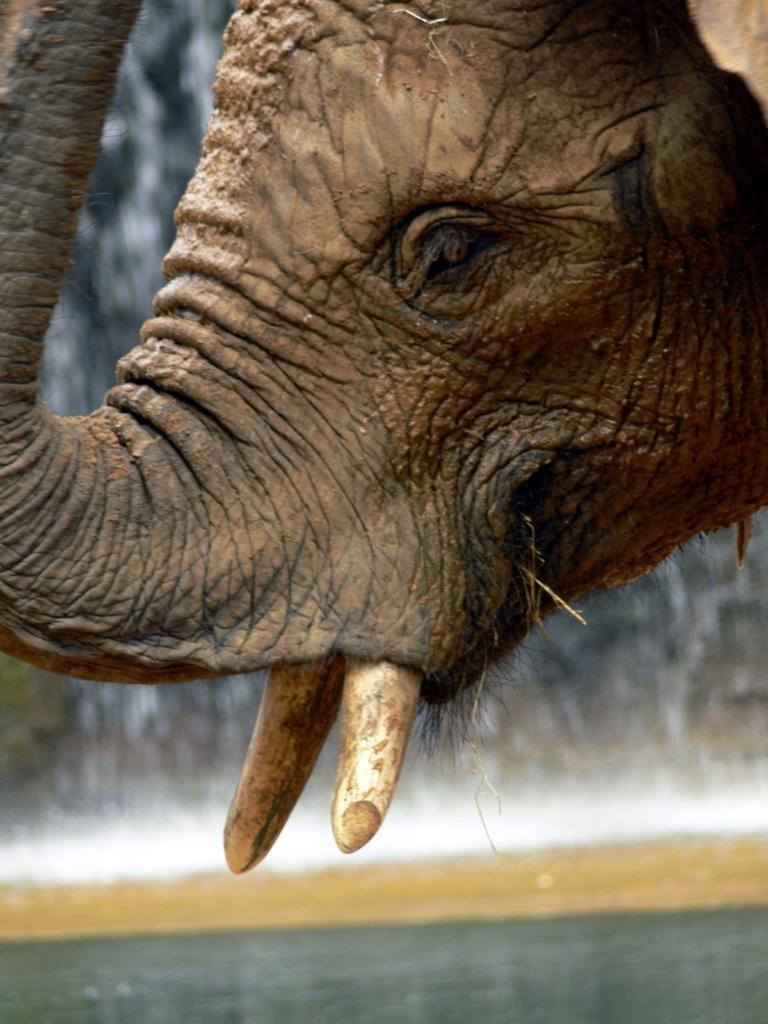What animal is the main subject of the picture? There is an elephant in the picture. What specific parts of the elephant are visible? Only the eye, trunk, and tusks of the elephant are visible. What natural feature can be seen in the background of the picture? There is a waterfall in the background of the picture. What is present at the bottom of the picture? There is water visible at the bottom of the picture. What type of flowers can be seen growing near the elephant's feet in the image? There are no flowers visible in the image; only the eye, trunk, and tusks of the elephant are visible, along with a waterfall in the background and water at the bottom of the picture. 